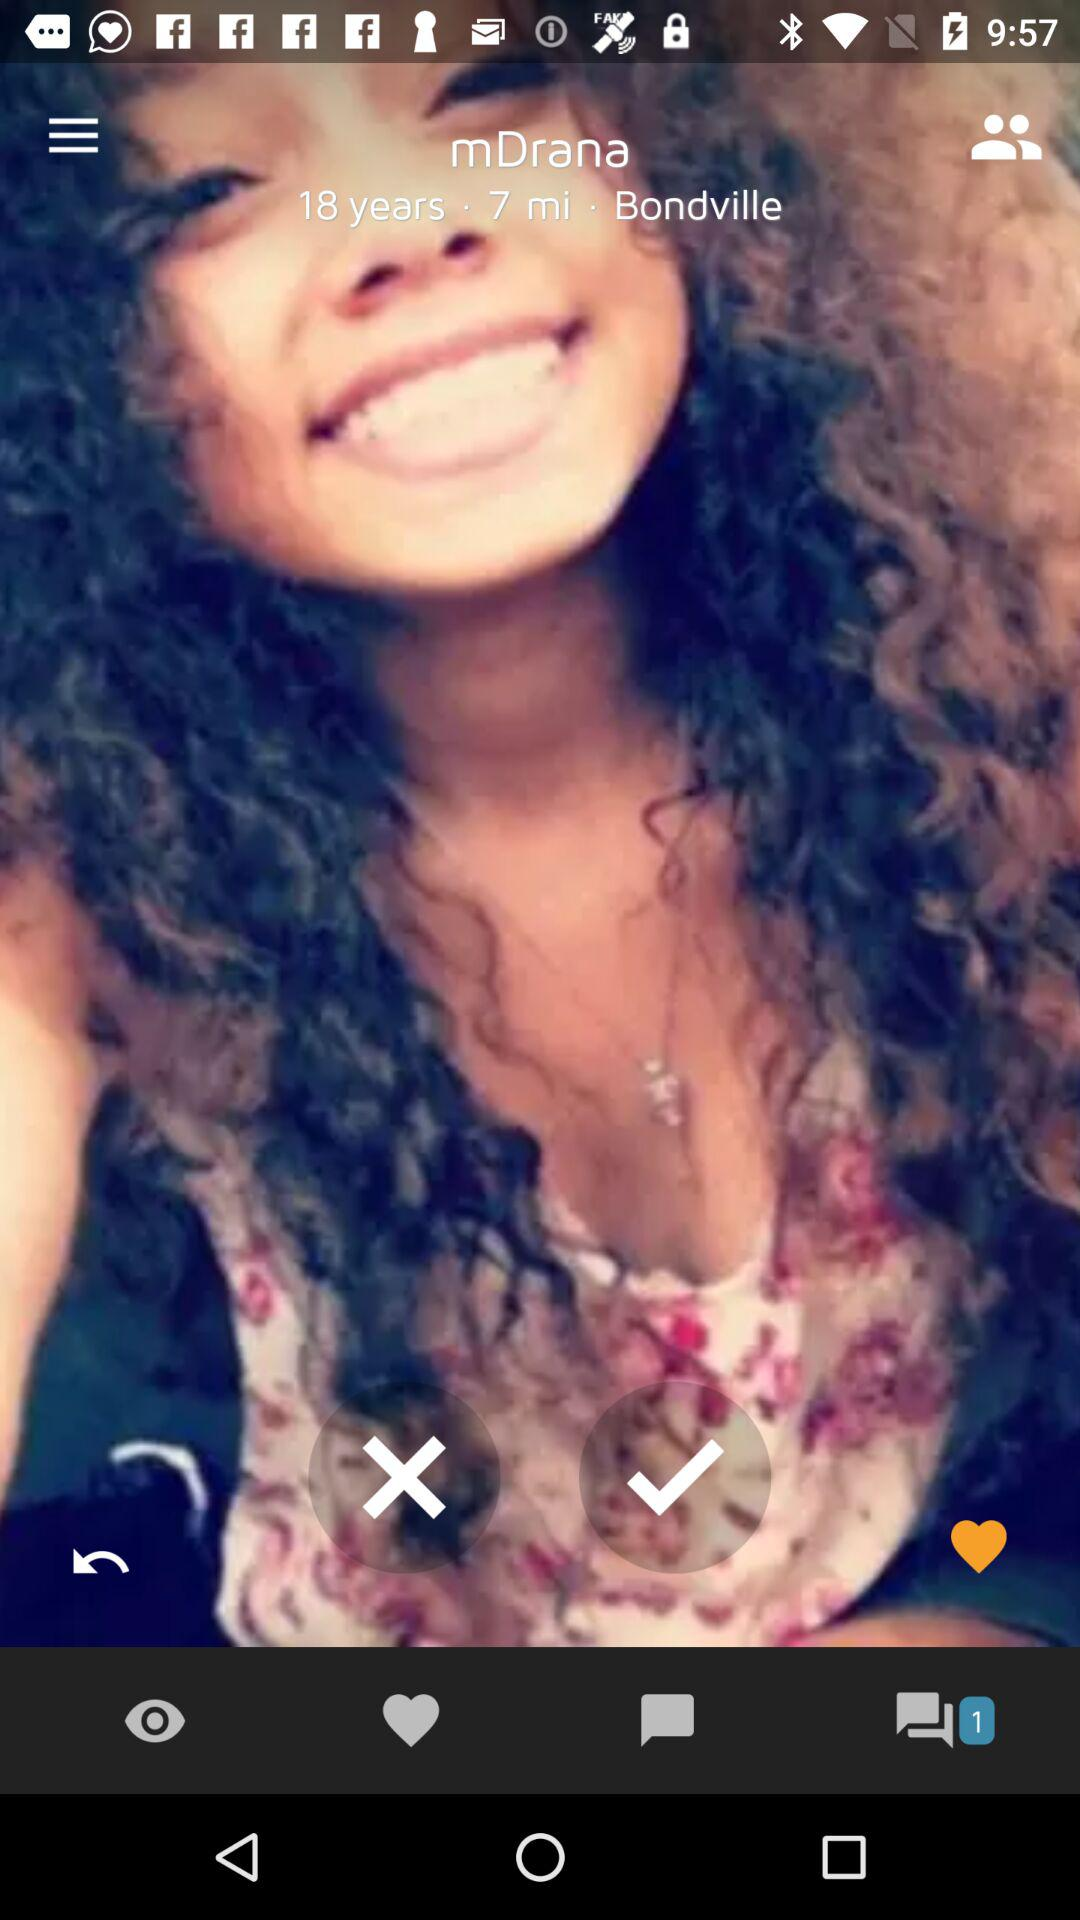What is the location of "mDrana"? The location is Bondville. 